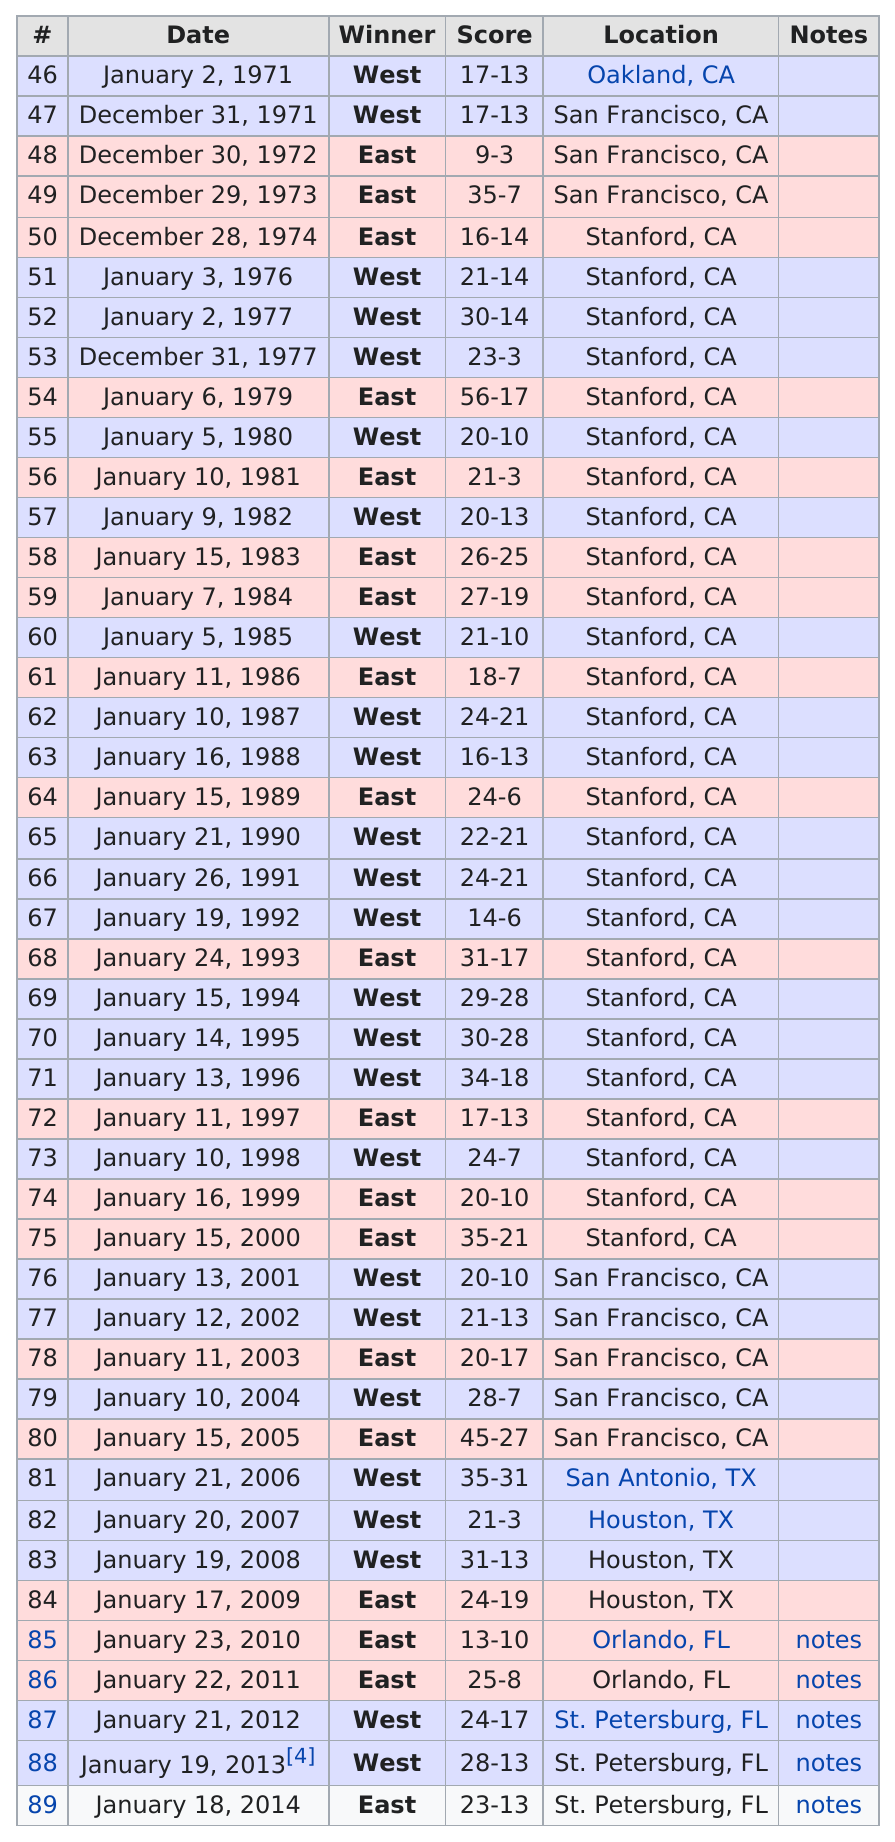Draw attention to some important aspects in this diagram. The total score of the 2003 East-West Shrine Game was either more or less than 35. The game with the largest difference between the winning and losing scores was 54. The West team had the longest consecutive winning streak, which was a remarkable achievement. The first game played in Houston, Texas was on January 20, 2007. In 2008, the West team scored the most points. 